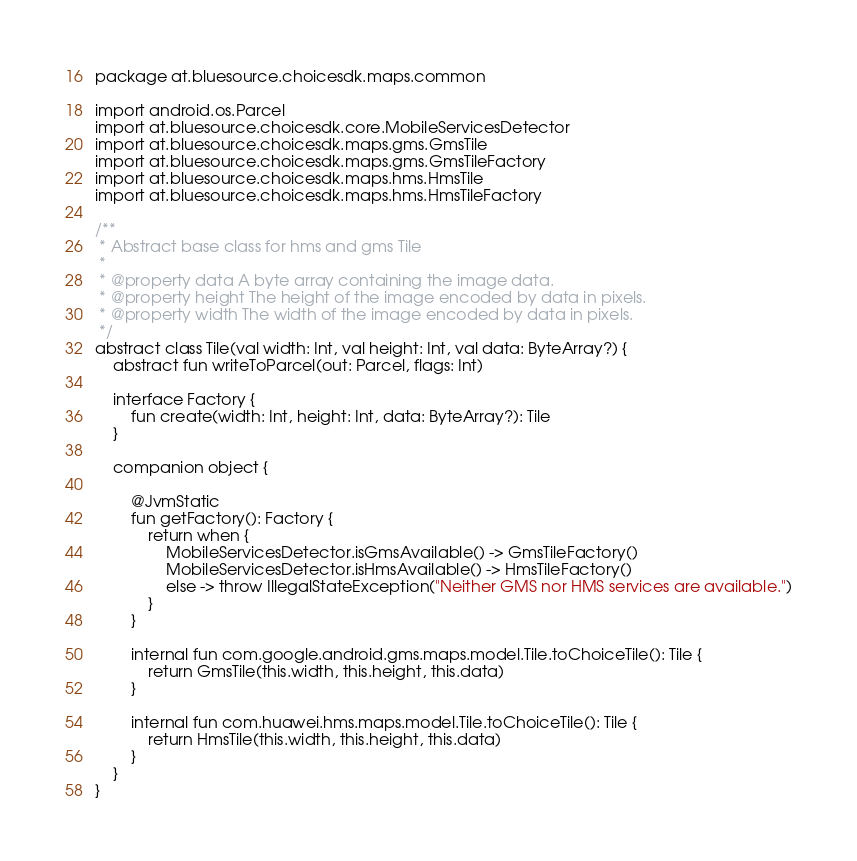Convert code to text. <code><loc_0><loc_0><loc_500><loc_500><_Kotlin_>package at.bluesource.choicesdk.maps.common

import android.os.Parcel
import at.bluesource.choicesdk.core.MobileServicesDetector
import at.bluesource.choicesdk.maps.gms.GmsTile
import at.bluesource.choicesdk.maps.gms.GmsTileFactory
import at.bluesource.choicesdk.maps.hms.HmsTile
import at.bluesource.choicesdk.maps.hms.HmsTileFactory

/**
 * Abstract base class for hms and gms Tile
 *
 * @property data A byte array containing the image data.
 * @property height The height of the image encoded by data in pixels.
 * @property width The width of the image encoded by data in pixels.
 */
abstract class Tile(val width: Int, val height: Int, val data: ByteArray?) {
    abstract fun writeToParcel(out: Parcel, flags: Int)

    interface Factory {
        fun create(width: Int, height: Int, data: ByteArray?): Tile
    }

    companion object {

        @JvmStatic
        fun getFactory(): Factory {
            return when {
                MobileServicesDetector.isGmsAvailable() -> GmsTileFactory()
                MobileServicesDetector.isHmsAvailable() -> HmsTileFactory()
                else -> throw IllegalStateException("Neither GMS nor HMS services are available.")
            }
        }

        internal fun com.google.android.gms.maps.model.Tile.toChoiceTile(): Tile {
            return GmsTile(this.width, this.height, this.data)
        }

        internal fun com.huawei.hms.maps.model.Tile.toChoiceTile(): Tile {
            return HmsTile(this.width, this.height, this.data)
        }
    }
}</code> 